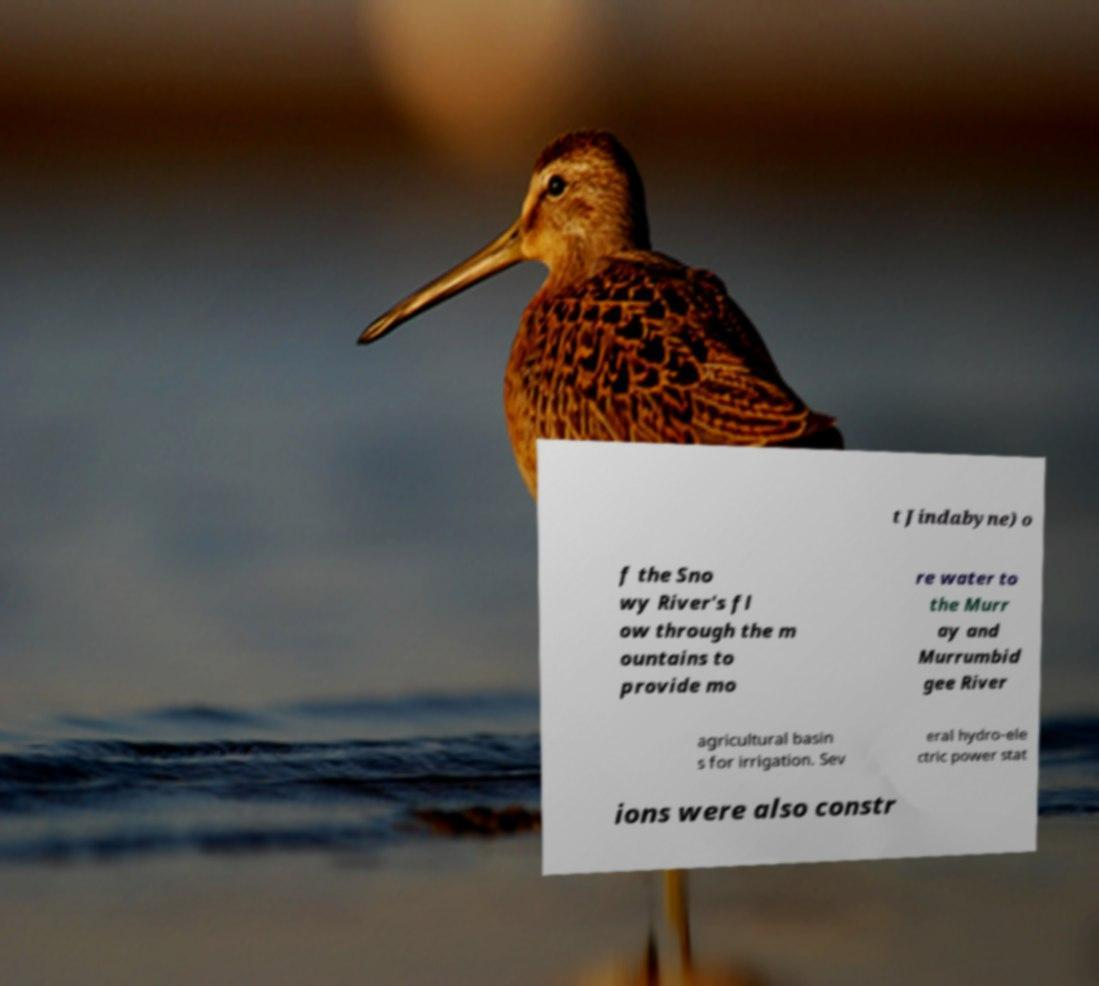Please read and relay the text visible in this image. What does it say? t Jindabyne) o f the Sno wy River's fl ow through the m ountains to provide mo re water to the Murr ay and Murrumbid gee River agricultural basin s for irrigation. Sev eral hydro-ele ctric power stat ions were also constr 